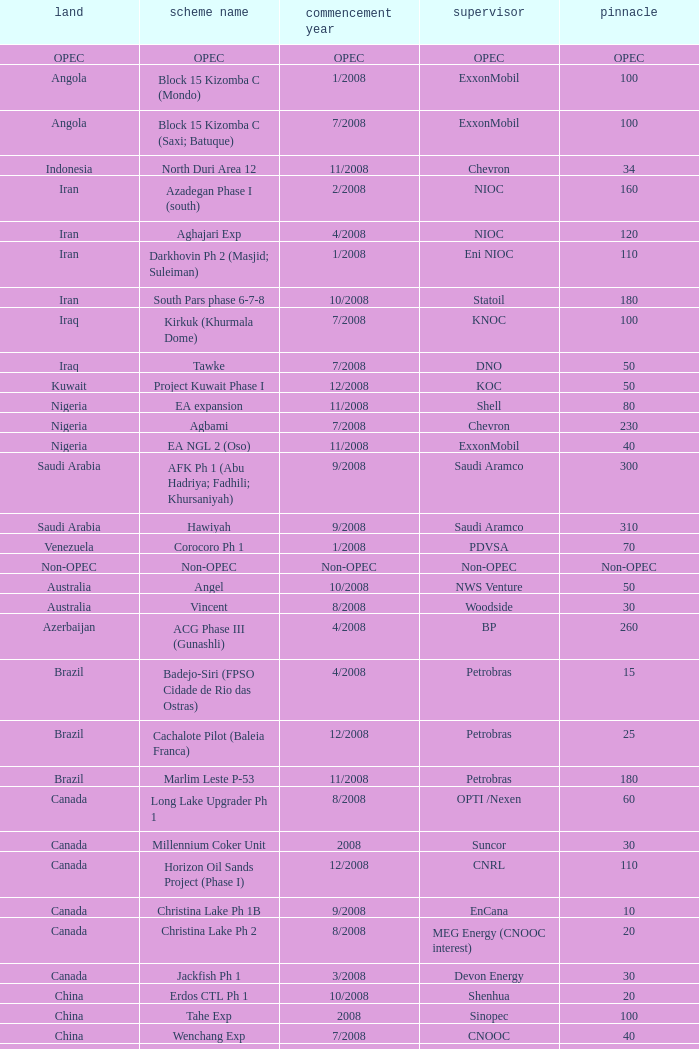What is the Project Name with a Country that is kazakhstan and a Peak that is 150? Dunga. Write the full table. {'header': ['land', 'scheme name', 'commencement year', 'supervisor', 'pinnacle'], 'rows': [['OPEC', 'OPEC', 'OPEC', 'OPEC', 'OPEC'], ['Angola', 'Block 15 Kizomba C (Mondo)', '1/2008', 'ExxonMobil', '100'], ['Angola', 'Block 15 Kizomba C (Saxi; Batuque)', '7/2008', 'ExxonMobil', '100'], ['Indonesia', 'North Duri Area 12', '11/2008', 'Chevron', '34'], ['Iran', 'Azadegan Phase I (south)', '2/2008', 'NIOC', '160'], ['Iran', 'Aghajari Exp', '4/2008', 'NIOC', '120'], ['Iran', 'Darkhovin Ph 2 (Masjid; Suleiman)', '1/2008', 'Eni NIOC', '110'], ['Iran', 'South Pars phase 6-7-8', '10/2008', 'Statoil', '180'], ['Iraq', 'Kirkuk (Khurmala Dome)', '7/2008', 'KNOC', '100'], ['Iraq', 'Tawke', '7/2008', 'DNO', '50'], ['Kuwait', 'Project Kuwait Phase I', '12/2008', 'KOC', '50'], ['Nigeria', 'EA expansion', '11/2008', 'Shell', '80'], ['Nigeria', 'Agbami', '7/2008', 'Chevron', '230'], ['Nigeria', 'EA NGL 2 (Oso)', '11/2008', 'ExxonMobil', '40'], ['Saudi Arabia', 'AFK Ph 1 (Abu Hadriya; Fadhili; Khursaniyah)', '9/2008', 'Saudi Aramco', '300'], ['Saudi Arabia', 'Hawiyah', '9/2008', 'Saudi Aramco', '310'], ['Venezuela', 'Corocoro Ph 1', '1/2008', 'PDVSA', '70'], ['Non-OPEC', 'Non-OPEC', 'Non-OPEC', 'Non-OPEC', 'Non-OPEC'], ['Australia', 'Angel', '10/2008', 'NWS Venture', '50'], ['Australia', 'Vincent', '8/2008', 'Woodside', '30'], ['Azerbaijan', 'ACG Phase III (Gunashli)', '4/2008', 'BP', '260'], ['Brazil', 'Badejo-Siri (FPSO Cidade de Rio das Ostras)', '4/2008', 'Petrobras', '15'], ['Brazil', 'Cachalote Pilot (Baleia Franca)', '12/2008', 'Petrobras', '25'], ['Brazil', 'Marlim Leste P-53', '11/2008', 'Petrobras', '180'], ['Canada', 'Long Lake Upgrader Ph 1', '8/2008', 'OPTI /Nexen', '60'], ['Canada', 'Millennium Coker Unit', '2008', 'Suncor', '30'], ['Canada', 'Horizon Oil Sands Project (Phase I)', '12/2008', 'CNRL', '110'], ['Canada', 'Christina Lake Ph 1B', '9/2008', 'EnCana', '10'], ['Canada', 'Christina Lake Ph 2', '8/2008', 'MEG Energy (CNOOC interest)', '20'], ['Canada', 'Jackfish Ph 1', '3/2008', 'Devon Energy', '30'], ['China', 'Erdos CTL Ph 1', '10/2008', 'Shenhua', '20'], ['China', 'Tahe Exp', '2008', 'Sinopec', '100'], ['China', 'Wenchang Exp', '7/2008', 'CNOOC', '40'], ['China', 'Xijiang 23-1', '6/2008', 'CNOOC', '40'], ['Congo', 'Moho Bilondo', '4/2008', 'Total', '90'], ['Egypt', 'Saqqara', '3/2008', 'BP', '40'], ['India', 'MA field (KG-D6)', '9/2008', 'Reliance', '40'], ['Kazakhstan', 'Dunga', '3/2008', 'Maersk', '150'], ['Kazakhstan', 'Komsomolskoe', '5/2008', 'Petrom', '10'], ['Mexico', '( Chicontepec ) Exp 1', '2008', 'PEMEX', '200'], ['Mexico', 'Antonio J Bermudez Exp', '5/2008', 'PEMEX', '20'], ['Mexico', 'Bellota Chinchorro Exp', '5/2008', 'PEMEX', '20'], ['Mexico', 'Ixtal Manik', '2008', 'PEMEX', '55'], ['Mexico', 'Jujo Tecominoacan Exp', '2008', 'PEMEX', '15'], ['Norway', 'Alvheim; Volund; Vilje', '6/2008', 'Marathon', '100'], ['Norway', 'Volve', '2/2008', 'StatoilHydro', '35'], ['Oman', 'Mukhaizna EOR Ph 1', '2008', 'Occidental', '40'], ['Philippines', 'Galoc', '10/2008', 'GPC', '15'], ['Russia', 'Talakan Ph 1', '10/2008', 'Surgutneftegaz', '60'], ['Russia', 'Verkhnechonsk Ph 1 (early oil)', '10/2008', 'TNK-BP Rosneft', '20'], ['Russia', 'Yuzhno-Khylchuyuskoye "YK" Ph 1', '8/2008', 'Lukoil ConocoPhillips', '75'], ['Thailand', 'Bualuang', '8/2008', 'Salamander', '10'], ['UK', 'Britannia Satellites (Callanish; Brodgar)', '7/2008', 'Conoco Phillips', '25'], ['USA', 'Blind Faith', '11/2008', 'Chevron', '45'], ['USA', 'Neptune', '7/2008', 'BHP Billiton', '25'], ['USA', 'Oooguruk', '6/2008', 'Pioneer', '15'], ['USA', 'Qannik', '7/2008', 'ConocoPhillips', '4'], ['USA', 'Thunder Horse', '6/2008', 'BP', '210'], ['USA', 'Ursa Princess Exp', '1/2008', 'Shell', '30'], ['Vietnam', 'Ca Ngu Vang (Golden Tuna)', '7/2008', 'HVJOC', '15'], ['Vietnam', 'Su Tu Vang', '10/2008', 'Cuu Long Joint', '40'], ['Vietnam', 'Song Doc', '12/2008', 'Talisman', '10']]} 